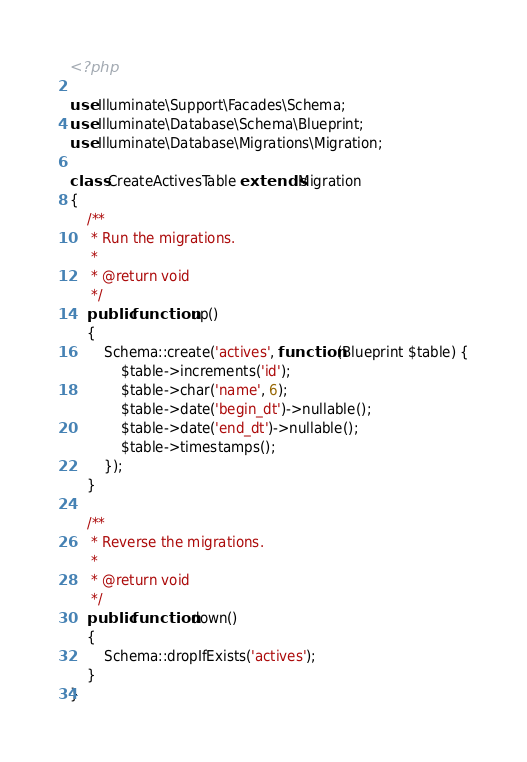<code> <loc_0><loc_0><loc_500><loc_500><_PHP_><?php

use Illuminate\Support\Facades\Schema;
use Illuminate\Database\Schema\Blueprint;
use Illuminate\Database\Migrations\Migration;

class CreateActivesTable extends Migration
{
    /**
     * Run the migrations.
     *
     * @return void
     */
    public function up()
    {
        Schema::create('actives', function (Blueprint $table) {
            $table->increments('id');
            $table->char('name', 6);
            $table->date('begin_dt')->nullable();
            $table->date('end_dt')->nullable();
            $table->timestamps();
        });
    }

    /**
     * Reverse the migrations.
     *
     * @return void
     */
    public function down()
    {
        Schema::dropIfExists('actives');
    }
}
</code> 